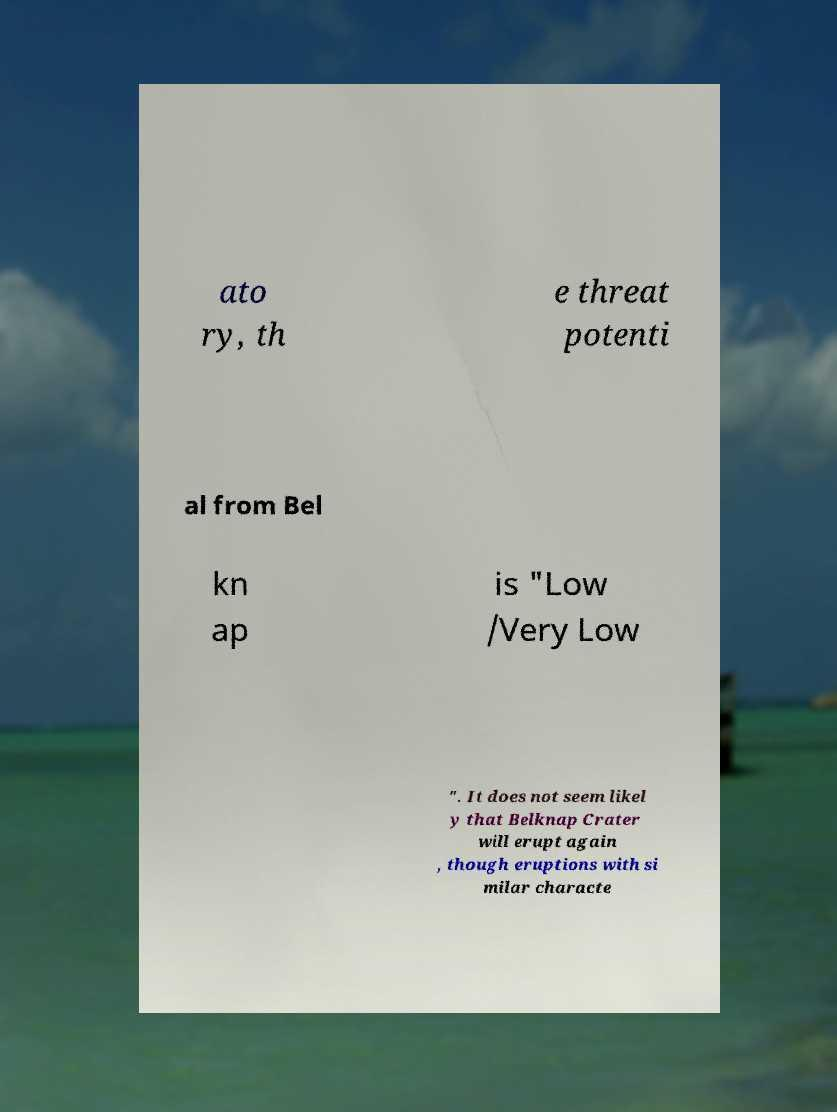There's text embedded in this image that I need extracted. Can you transcribe it verbatim? ato ry, th e threat potenti al from Bel kn ap is "Low /Very Low ". It does not seem likel y that Belknap Crater will erupt again , though eruptions with si milar characte 